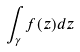Convert formula to latex. <formula><loc_0><loc_0><loc_500><loc_500>\int _ { \gamma } f ( z ) d z</formula> 